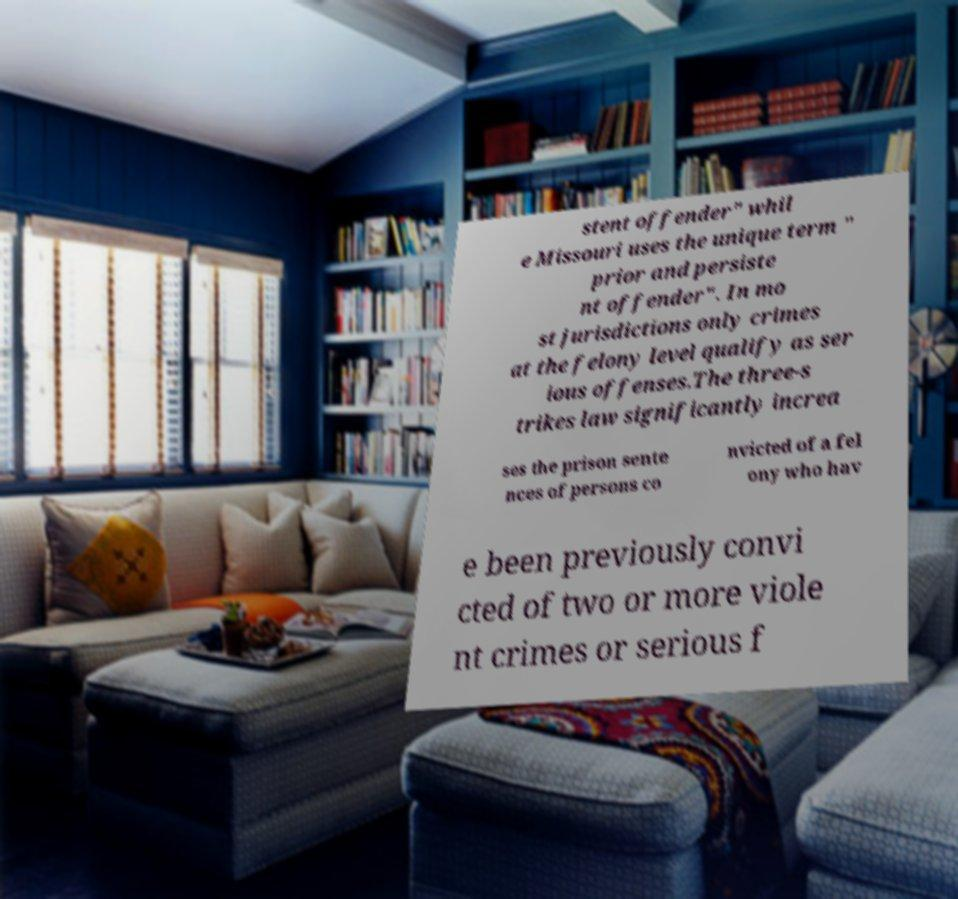I need the written content from this picture converted into text. Can you do that? stent offender" whil e Missouri uses the unique term " prior and persiste nt offender". In mo st jurisdictions only crimes at the felony level qualify as ser ious offenses.The three-s trikes law significantly increa ses the prison sente nces of persons co nvicted of a fel ony who hav e been previously convi cted of two or more viole nt crimes or serious f 